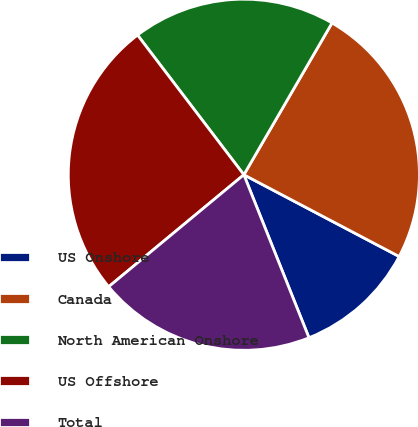<chart> <loc_0><loc_0><loc_500><loc_500><pie_chart><fcel>US Onshore<fcel>Canada<fcel>North American Onshore<fcel>US Offshore<fcel>Total<nl><fcel>11.24%<fcel>24.34%<fcel>18.73%<fcel>25.66%<fcel>20.04%<nl></chart> 